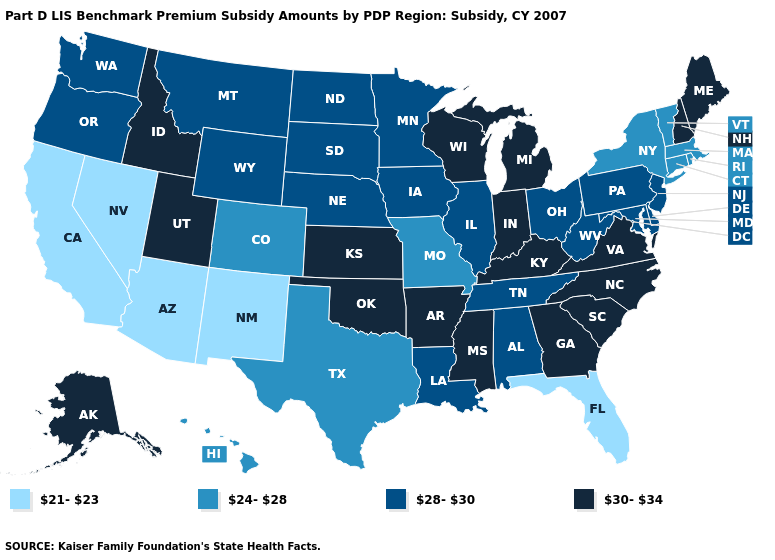Is the legend a continuous bar?
Keep it brief. No. Does Idaho have the highest value in the West?
Short answer required. Yes. What is the value of Utah?
Be succinct. 30-34. What is the lowest value in the MidWest?
Give a very brief answer. 24-28. What is the value of Wisconsin?
Be succinct. 30-34. Which states have the lowest value in the USA?
Short answer required. Arizona, California, Florida, Nevada, New Mexico. Does Missouri have the lowest value in the MidWest?
Short answer required. Yes. What is the value of Indiana?
Be succinct. 30-34. Among the states that border Texas , does New Mexico have the lowest value?
Quick response, please. Yes. Does Florida have the lowest value in the South?
Keep it brief. Yes. Name the states that have a value in the range 21-23?
Give a very brief answer. Arizona, California, Florida, Nevada, New Mexico. Among the states that border New York , does Massachusetts have the lowest value?
Give a very brief answer. Yes. Name the states that have a value in the range 24-28?
Be succinct. Colorado, Connecticut, Hawaii, Massachusetts, Missouri, New York, Rhode Island, Texas, Vermont. What is the value of North Dakota?
Keep it brief. 28-30. What is the value of North Carolina?
Write a very short answer. 30-34. 